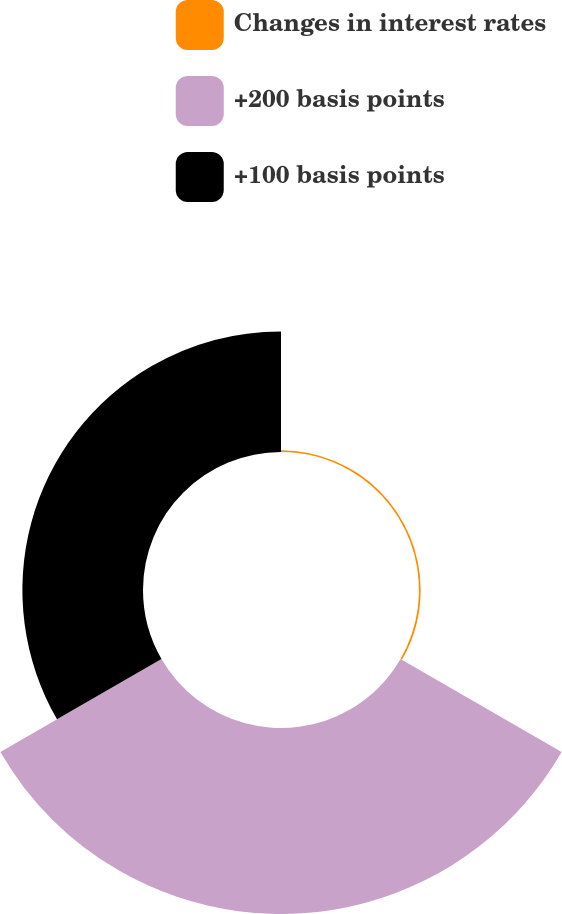<chart> <loc_0><loc_0><loc_500><loc_500><pie_chart><fcel>Changes in interest rates<fcel>+200 basis points<fcel>+100 basis points<nl><fcel>0.54%<fcel>60.34%<fcel>39.13%<nl></chart> 